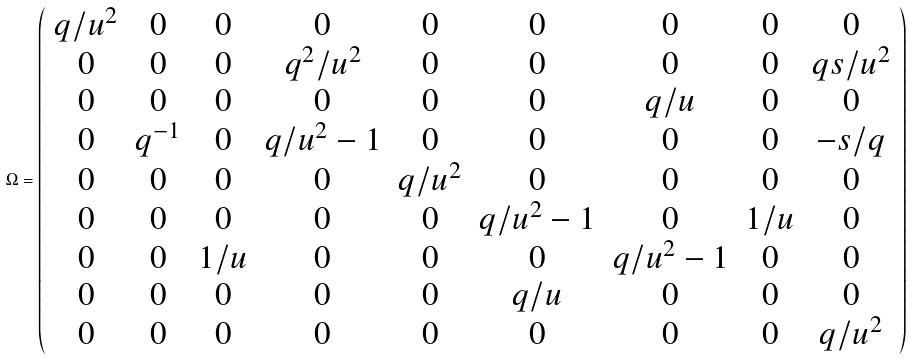Convert formula to latex. <formula><loc_0><loc_0><loc_500><loc_500>\Omega = \left ( \begin{array} { c c c c c c c c c } q / u ^ { 2 } & 0 & 0 & 0 & 0 & 0 & 0 & 0 & 0 \\ 0 & 0 & 0 & q ^ { 2 } / u ^ { 2 } & 0 & 0 & 0 & 0 & q s / u ^ { 2 } \\ 0 & 0 & 0 & 0 & 0 & 0 & q / u & 0 & 0 \\ 0 & q ^ { - 1 } & 0 & q / u ^ { 2 } - 1 & 0 & 0 & 0 & 0 & - s / q \\ 0 & 0 & 0 & 0 & q / u ^ { 2 } & 0 & 0 & 0 & 0 \\ 0 & 0 & 0 & 0 & 0 & q / u ^ { 2 } - 1 & 0 & 1 / u & 0 \\ 0 & 0 & 1 / u & 0 & 0 & 0 & q / u ^ { 2 } - 1 & 0 & 0 \\ 0 & 0 & 0 & 0 & 0 & q / u & 0 & 0 & 0 \\ 0 & 0 & 0 & 0 & 0 & 0 & 0 & 0 & q / u ^ { 2 } \\ \end{array} \right )</formula> 